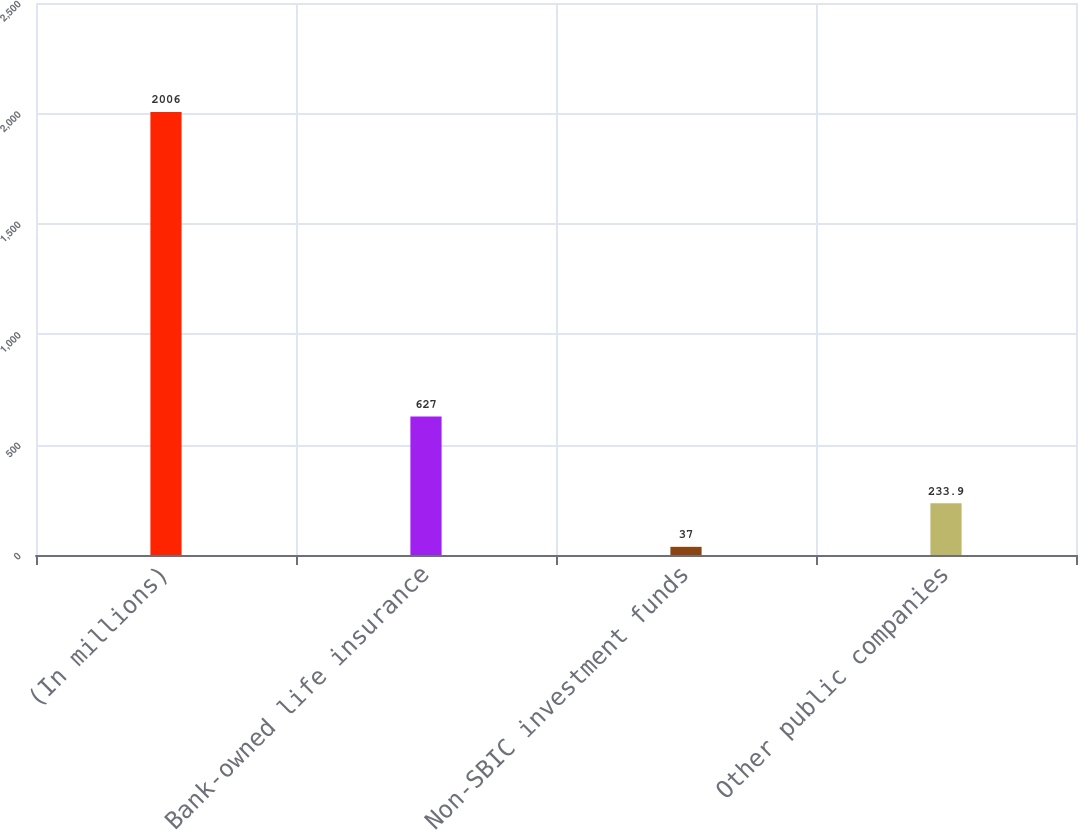Convert chart to OTSL. <chart><loc_0><loc_0><loc_500><loc_500><bar_chart><fcel>(In millions)<fcel>Bank-owned life insurance<fcel>Non-SBIC investment funds<fcel>Other public companies<nl><fcel>2006<fcel>627<fcel>37<fcel>233.9<nl></chart> 